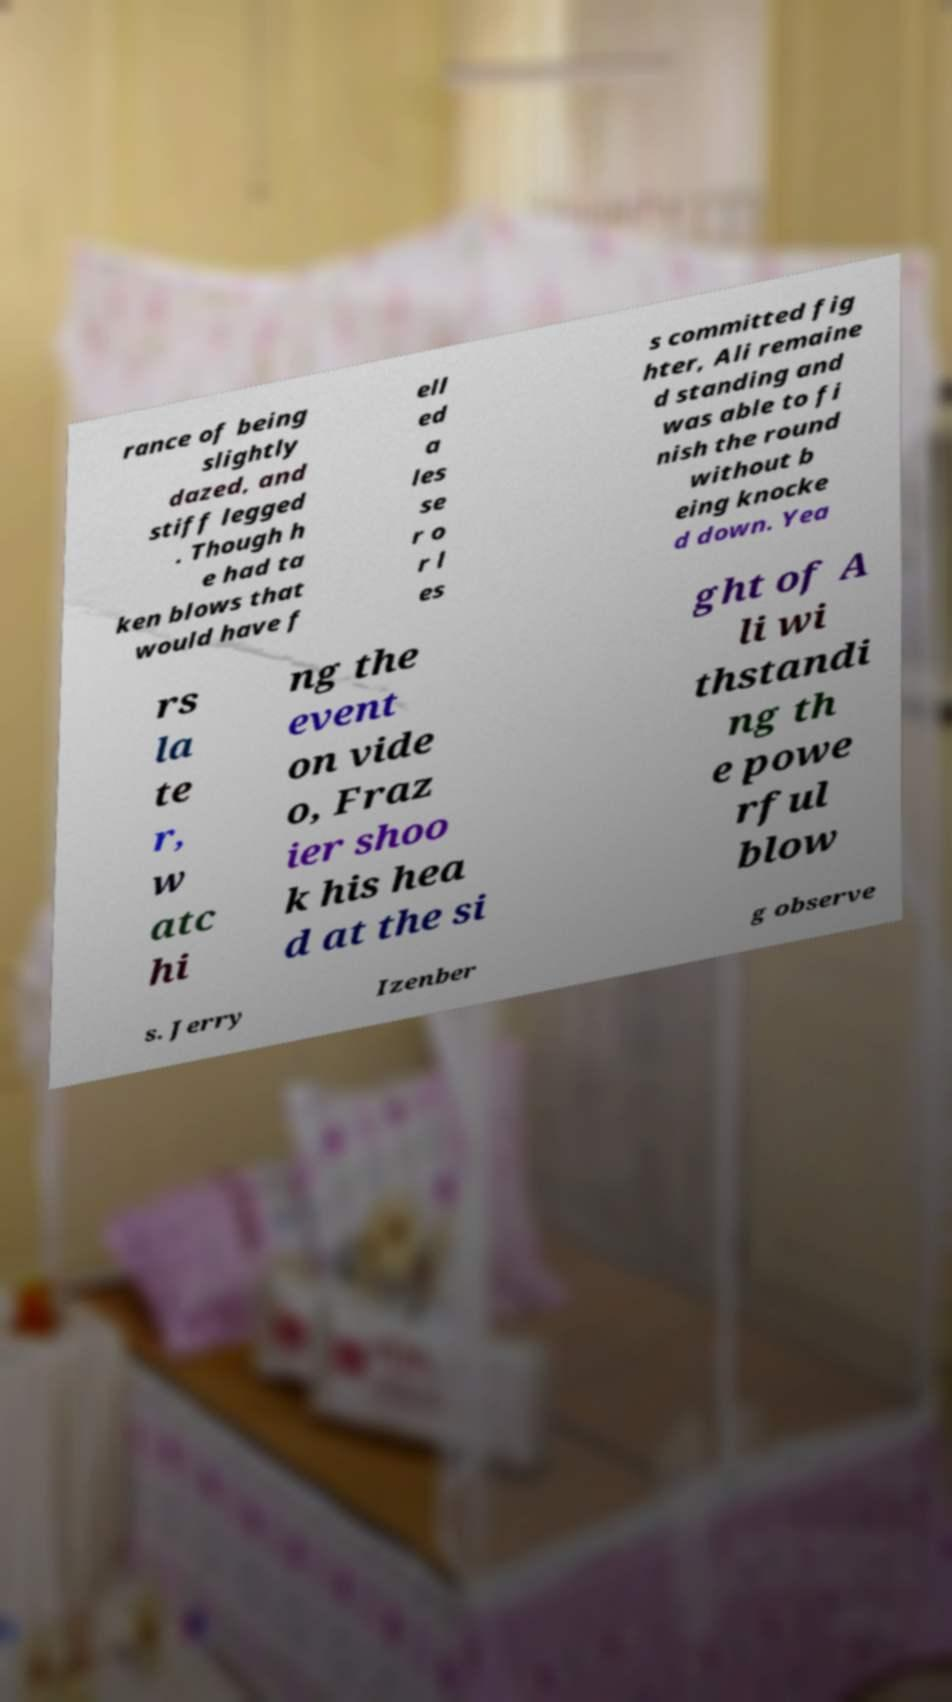Could you assist in decoding the text presented in this image and type it out clearly? rance of being slightly dazed, and stiff legged . Though h e had ta ken blows that would have f ell ed a les se r o r l es s committed fig hter, Ali remaine d standing and was able to fi nish the round without b eing knocke d down. Yea rs la te r, w atc hi ng the event on vide o, Fraz ier shoo k his hea d at the si ght of A li wi thstandi ng th e powe rful blow s. Jerry Izenber g observe 